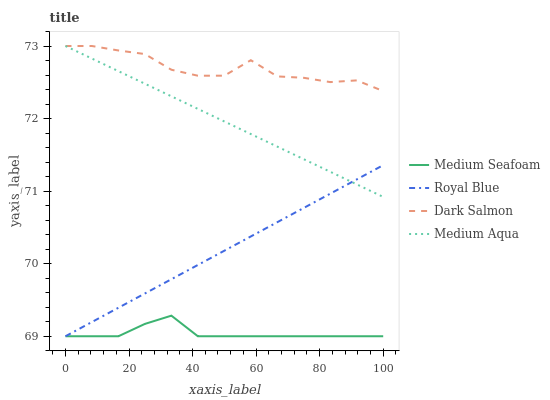Does Medium Seafoam have the minimum area under the curve?
Answer yes or no. Yes. Does Dark Salmon have the maximum area under the curve?
Answer yes or no. Yes. Does Medium Aqua have the minimum area under the curve?
Answer yes or no. No. Does Medium Aqua have the maximum area under the curve?
Answer yes or no. No. Is Royal Blue the smoothest?
Answer yes or no. Yes. Is Dark Salmon the roughest?
Answer yes or no. Yes. Is Medium Aqua the smoothest?
Answer yes or no. No. Is Medium Aqua the roughest?
Answer yes or no. No. Does Royal Blue have the lowest value?
Answer yes or no. Yes. Does Medium Aqua have the lowest value?
Answer yes or no. No. Does Dark Salmon have the highest value?
Answer yes or no. Yes. Does Medium Seafoam have the highest value?
Answer yes or no. No. Is Medium Seafoam less than Dark Salmon?
Answer yes or no. Yes. Is Dark Salmon greater than Medium Seafoam?
Answer yes or no. Yes. Does Royal Blue intersect Medium Seafoam?
Answer yes or no. Yes. Is Royal Blue less than Medium Seafoam?
Answer yes or no. No. Is Royal Blue greater than Medium Seafoam?
Answer yes or no. No. Does Medium Seafoam intersect Dark Salmon?
Answer yes or no. No. 